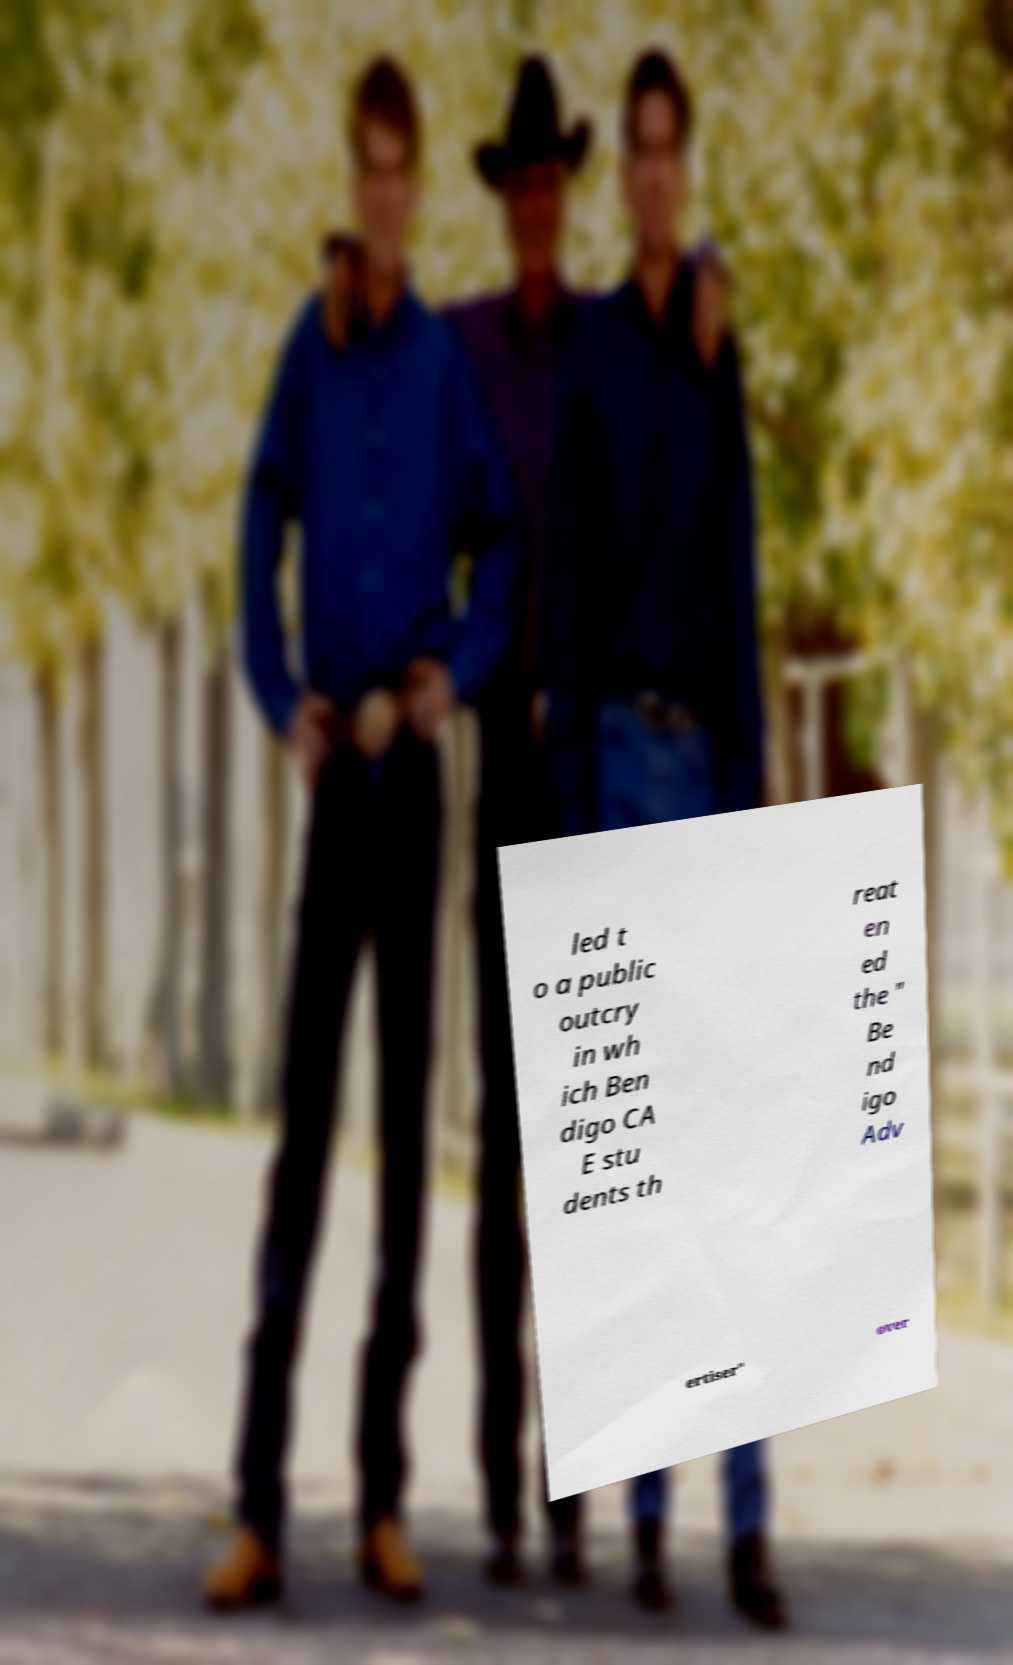Can you accurately transcribe the text from the provided image for me? led t o a public outcry in wh ich Ben digo CA E stu dents th reat en ed the " Be nd igo Adv ertiser" over 